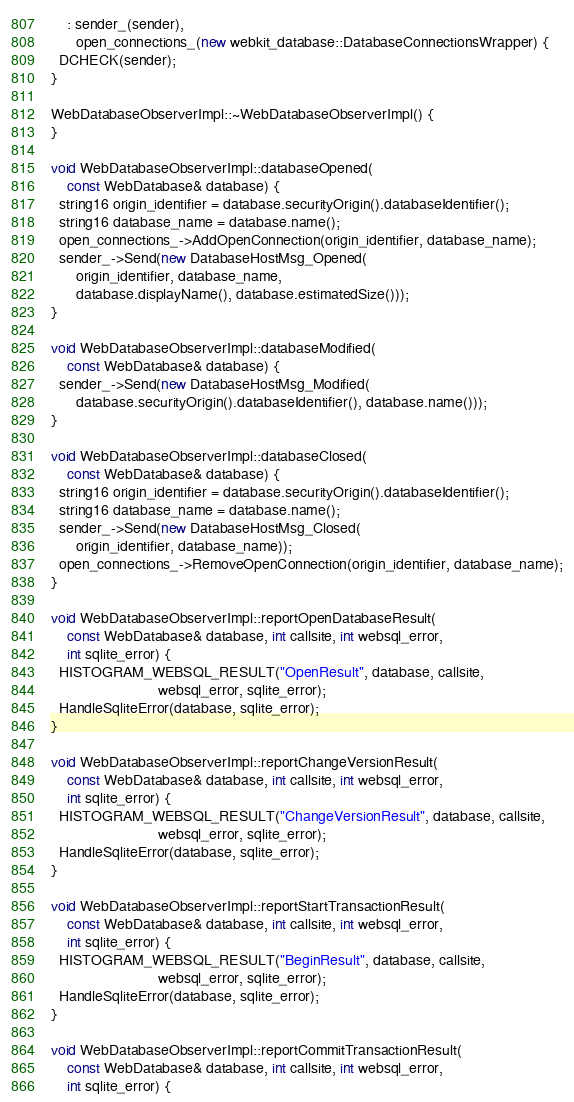Convert code to text. <code><loc_0><loc_0><loc_500><loc_500><_C++_>    : sender_(sender),
      open_connections_(new webkit_database::DatabaseConnectionsWrapper) {
  DCHECK(sender);
}

WebDatabaseObserverImpl::~WebDatabaseObserverImpl() {
}

void WebDatabaseObserverImpl::databaseOpened(
    const WebDatabase& database) {
  string16 origin_identifier = database.securityOrigin().databaseIdentifier();
  string16 database_name = database.name();
  open_connections_->AddOpenConnection(origin_identifier, database_name);
  sender_->Send(new DatabaseHostMsg_Opened(
      origin_identifier, database_name,
      database.displayName(), database.estimatedSize()));
}

void WebDatabaseObserverImpl::databaseModified(
    const WebDatabase& database) {
  sender_->Send(new DatabaseHostMsg_Modified(
      database.securityOrigin().databaseIdentifier(), database.name()));
}

void WebDatabaseObserverImpl::databaseClosed(
    const WebDatabase& database) {
  string16 origin_identifier = database.securityOrigin().databaseIdentifier();
  string16 database_name = database.name();
  sender_->Send(new DatabaseHostMsg_Closed(
      origin_identifier, database_name));
  open_connections_->RemoveOpenConnection(origin_identifier, database_name);
}

void WebDatabaseObserverImpl::reportOpenDatabaseResult(
    const WebDatabase& database, int callsite, int websql_error,
    int sqlite_error) {
  HISTOGRAM_WEBSQL_RESULT("OpenResult", database, callsite,
                          websql_error, sqlite_error);
  HandleSqliteError(database, sqlite_error);
}

void WebDatabaseObserverImpl::reportChangeVersionResult(
    const WebDatabase& database, int callsite, int websql_error,
    int sqlite_error) {
  HISTOGRAM_WEBSQL_RESULT("ChangeVersionResult", database, callsite,
                          websql_error, sqlite_error);
  HandleSqliteError(database, sqlite_error);
}

void WebDatabaseObserverImpl::reportStartTransactionResult(
    const WebDatabase& database, int callsite, int websql_error,
    int sqlite_error) {
  HISTOGRAM_WEBSQL_RESULT("BeginResult", database, callsite,
                          websql_error, sqlite_error);
  HandleSqliteError(database, sqlite_error);
}

void WebDatabaseObserverImpl::reportCommitTransactionResult(
    const WebDatabase& database, int callsite, int websql_error,
    int sqlite_error) {</code> 